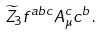<formula> <loc_0><loc_0><loc_500><loc_500>\widetilde { Z } _ { 3 } f ^ { a b c } A ^ { c } _ { \mu } c ^ { b } \, .</formula> 